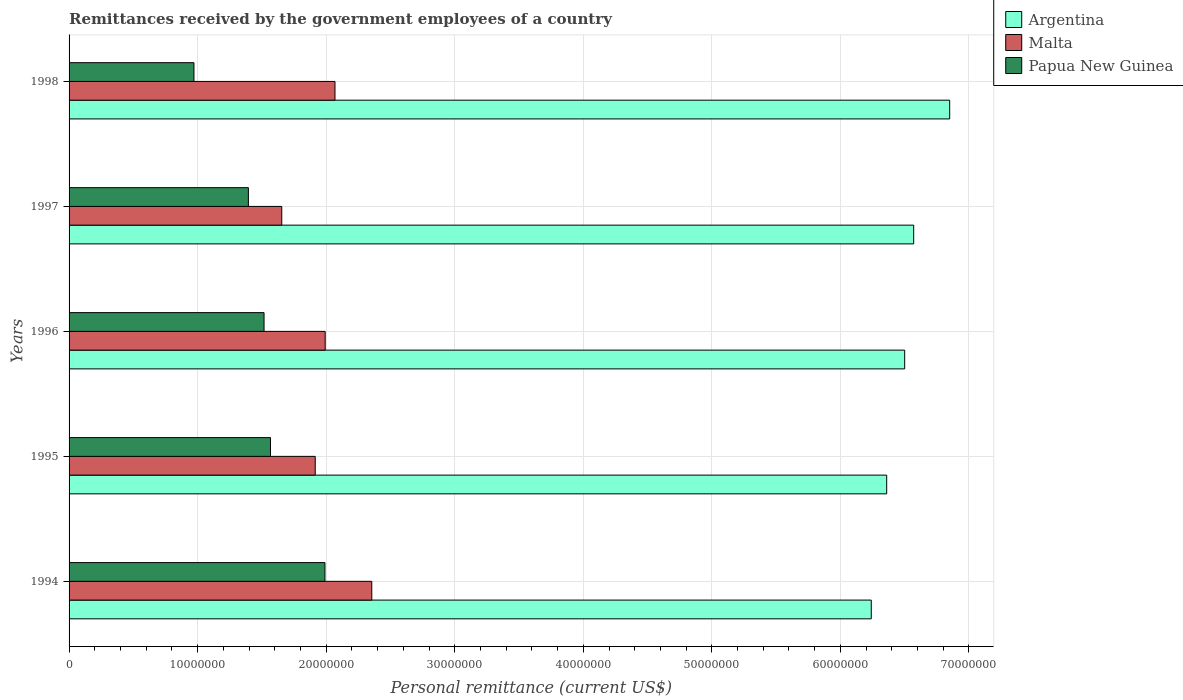How many different coloured bars are there?
Your answer should be very brief. 3. Are the number of bars per tick equal to the number of legend labels?
Offer a terse response. Yes. Are the number of bars on each tick of the Y-axis equal?
Provide a short and direct response. Yes. What is the remittances received by the government employees in Argentina in 1996?
Provide a succinct answer. 6.50e+07. Across all years, what is the maximum remittances received by the government employees in Papua New Guinea?
Offer a very short reply. 1.99e+07. Across all years, what is the minimum remittances received by the government employees in Malta?
Provide a short and direct response. 1.65e+07. In which year was the remittances received by the government employees in Papua New Guinea maximum?
Your answer should be compact. 1994. In which year was the remittances received by the government employees in Malta minimum?
Provide a succinct answer. 1997. What is the total remittances received by the government employees in Argentina in the graph?
Keep it short and to the point. 3.25e+08. What is the difference between the remittances received by the government employees in Malta in 1994 and that in 1996?
Your answer should be compact. 3.62e+06. What is the difference between the remittances received by the government employees in Papua New Guinea in 1994 and the remittances received by the government employees in Malta in 1995?
Provide a succinct answer. 7.56e+05. What is the average remittances received by the government employees in Papua New Guinea per year?
Keep it short and to the point. 1.49e+07. In the year 1994, what is the difference between the remittances received by the government employees in Malta and remittances received by the government employees in Papua New Guinea?
Give a very brief answer. 3.64e+06. What is the ratio of the remittances received by the government employees in Argentina in 1995 to that in 1997?
Your answer should be compact. 0.97. Is the remittances received by the government employees in Malta in 1994 less than that in 1998?
Your answer should be very brief. No. What is the difference between the highest and the second highest remittances received by the government employees in Malta?
Offer a terse response. 2.86e+06. What is the difference between the highest and the lowest remittances received by the government employees in Papua New Guinea?
Your answer should be very brief. 1.02e+07. In how many years, is the remittances received by the government employees in Argentina greater than the average remittances received by the government employees in Argentina taken over all years?
Provide a succinct answer. 2. Is the sum of the remittances received by the government employees in Argentina in 1994 and 1995 greater than the maximum remittances received by the government employees in Papua New Guinea across all years?
Offer a terse response. Yes. What does the 2nd bar from the top in 1996 represents?
Offer a very short reply. Malta. What does the 1st bar from the bottom in 1996 represents?
Your answer should be very brief. Argentina. How many bars are there?
Keep it short and to the point. 15. Does the graph contain any zero values?
Keep it short and to the point. No. Does the graph contain grids?
Offer a terse response. Yes. How are the legend labels stacked?
Offer a very short reply. Vertical. What is the title of the graph?
Your response must be concise. Remittances received by the government employees of a country. Does "Myanmar" appear as one of the legend labels in the graph?
Your response must be concise. No. What is the label or title of the X-axis?
Offer a terse response. Personal remittance (current US$). What is the Personal remittance (current US$) in Argentina in 1994?
Your answer should be compact. 6.24e+07. What is the Personal remittance (current US$) in Malta in 1994?
Ensure brevity in your answer.  2.35e+07. What is the Personal remittance (current US$) of Papua New Guinea in 1994?
Ensure brevity in your answer.  1.99e+07. What is the Personal remittance (current US$) of Argentina in 1995?
Provide a short and direct response. 6.36e+07. What is the Personal remittance (current US$) of Malta in 1995?
Ensure brevity in your answer.  1.91e+07. What is the Personal remittance (current US$) in Papua New Guinea in 1995?
Your response must be concise. 1.57e+07. What is the Personal remittance (current US$) in Argentina in 1996?
Your answer should be very brief. 6.50e+07. What is the Personal remittance (current US$) in Malta in 1996?
Your answer should be very brief. 1.99e+07. What is the Personal remittance (current US$) of Papua New Guinea in 1996?
Your response must be concise. 1.52e+07. What is the Personal remittance (current US$) of Argentina in 1997?
Make the answer very short. 6.57e+07. What is the Personal remittance (current US$) of Malta in 1997?
Provide a succinct answer. 1.65e+07. What is the Personal remittance (current US$) of Papua New Guinea in 1997?
Your answer should be very brief. 1.39e+07. What is the Personal remittance (current US$) in Argentina in 1998?
Offer a very short reply. 6.85e+07. What is the Personal remittance (current US$) of Malta in 1998?
Give a very brief answer. 2.07e+07. What is the Personal remittance (current US$) in Papua New Guinea in 1998?
Give a very brief answer. 9.71e+06. Across all years, what is the maximum Personal remittance (current US$) in Argentina?
Offer a terse response. 6.85e+07. Across all years, what is the maximum Personal remittance (current US$) in Malta?
Offer a terse response. 2.35e+07. Across all years, what is the maximum Personal remittance (current US$) in Papua New Guinea?
Offer a very short reply. 1.99e+07. Across all years, what is the minimum Personal remittance (current US$) in Argentina?
Provide a succinct answer. 6.24e+07. Across all years, what is the minimum Personal remittance (current US$) in Malta?
Offer a very short reply. 1.65e+07. Across all years, what is the minimum Personal remittance (current US$) of Papua New Guinea?
Offer a terse response. 9.71e+06. What is the total Personal remittance (current US$) in Argentina in the graph?
Keep it short and to the point. 3.25e+08. What is the total Personal remittance (current US$) in Malta in the graph?
Ensure brevity in your answer.  9.98e+07. What is the total Personal remittance (current US$) in Papua New Guinea in the graph?
Provide a succinct answer. 7.44e+07. What is the difference between the Personal remittance (current US$) of Argentina in 1994 and that in 1995?
Give a very brief answer. -1.20e+06. What is the difference between the Personal remittance (current US$) of Malta in 1994 and that in 1995?
Ensure brevity in your answer.  4.40e+06. What is the difference between the Personal remittance (current US$) of Papua New Guinea in 1994 and that in 1995?
Make the answer very short. 4.24e+06. What is the difference between the Personal remittance (current US$) in Argentina in 1994 and that in 1996?
Offer a very short reply. -2.60e+06. What is the difference between the Personal remittance (current US$) of Malta in 1994 and that in 1996?
Your response must be concise. 3.62e+06. What is the difference between the Personal remittance (current US$) of Papua New Guinea in 1994 and that in 1996?
Provide a short and direct response. 4.74e+06. What is the difference between the Personal remittance (current US$) in Argentina in 1994 and that in 1997?
Your answer should be very brief. -3.30e+06. What is the difference between the Personal remittance (current US$) in Malta in 1994 and that in 1997?
Make the answer very short. 7.00e+06. What is the difference between the Personal remittance (current US$) in Papua New Guinea in 1994 and that in 1997?
Give a very brief answer. 5.96e+06. What is the difference between the Personal remittance (current US$) of Argentina in 1994 and that in 1998?
Offer a very short reply. -6.10e+06. What is the difference between the Personal remittance (current US$) of Malta in 1994 and that in 1998?
Offer a very short reply. 2.86e+06. What is the difference between the Personal remittance (current US$) in Papua New Guinea in 1994 and that in 1998?
Offer a very short reply. 1.02e+07. What is the difference between the Personal remittance (current US$) of Argentina in 1995 and that in 1996?
Provide a succinct answer. -1.40e+06. What is the difference between the Personal remittance (current US$) in Malta in 1995 and that in 1996?
Offer a very short reply. -7.74e+05. What is the difference between the Personal remittance (current US$) in Papua New Guinea in 1995 and that in 1996?
Your answer should be compact. 5.01e+05. What is the difference between the Personal remittance (current US$) in Argentina in 1995 and that in 1997?
Ensure brevity in your answer.  -2.10e+06. What is the difference between the Personal remittance (current US$) of Malta in 1995 and that in 1997?
Ensure brevity in your answer.  2.60e+06. What is the difference between the Personal remittance (current US$) of Papua New Guinea in 1995 and that in 1997?
Give a very brief answer. 1.72e+06. What is the difference between the Personal remittance (current US$) in Argentina in 1995 and that in 1998?
Keep it short and to the point. -4.90e+06. What is the difference between the Personal remittance (current US$) in Malta in 1995 and that in 1998?
Provide a short and direct response. -1.54e+06. What is the difference between the Personal remittance (current US$) of Papua New Guinea in 1995 and that in 1998?
Provide a succinct answer. 5.95e+06. What is the difference between the Personal remittance (current US$) of Argentina in 1996 and that in 1997?
Your answer should be compact. -7.00e+05. What is the difference between the Personal remittance (current US$) in Malta in 1996 and that in 1997?
Ensure brevity in your answer.  3.38e+06. What is the difference between the Personal remittance (current US$) of Papua New Guinea in 1996 and that in 1997?
Give a very brief answer. 1.22e+06. What is the difference between the Personal remittance (current US$) of Argentina in 1996 and that in 1998?
Provide a short and direct response. -3.50e+06. What is the difference between the Personal remittance (current US$) in Malta in 1996 and that in 1998?
Keep it short and to the point. -7.62e+05. What is the difference between the Personal remittance (current US$) of Papua New Guinea in 1996 and that in 1998?
Make the answer very short. 5.45e+06. What is the difference between the Personal remittance (current US$) in Argentina in 1997 and that in 1998?
Offer a terse response. -2.80e+06. What is the difference between the Personal remittance (current US$) in Malta in 1997 and that in 1998?
Your answer should be compact. -4.14e+06. What is the difference between the Personal remittance (current US$) in Papua New Guinea in 1997 and that in 1998?
Keep it short and to the point. 4.24e+06. What is the difference between the Personal remittance (current US$) of Argentina in 1994 and the Personal remittance (current US$) of Malta in 1995?
Your answer should be very brief. 4.33e+07. What is the difference between the Personal remittance (current US$) in Argentina in 1994 and the Personal remittance (current US$) in Papua New Guinea in 1995?
Your answer should be compact. 4.67e+07. What is the difference between the Personal remittance (current US$) in Malta in 1994 and the Personal remittance (current US$) in Papua New Guinea in 1995?
Make the answer very short. 7.88e+06. What is the difference between the Personal remittance (current US$) of Argentina in 1994 and the Personal remittance (current US$) of Malta in 1996?
Provide a succinct answer. 4.25e+07. What is the difference between the Personal remittance (current US$) of Argentina in 1994 and the Personal remittance (current US$) of Papua New Guinea in 1996?
Give a very brief answer. 4.72e+07. What is the difference between the Personal remittance (current US$) of Malta in 1994 and the Personal remittance (current US$) of Papua New Guinea in 1996?
Give a very brief answer. 8.38e+06. What is the difference between the Personal remittance (current US$) of Argentina in 1994 and the Personal remittance (current US$) of Malta in 1997?
Your answer should be compact. 4.59e+07. What is the difference between the Personal remittance (current US$) of Argentina in 1994 and the Personal remittance (current US$) of Papua New Guinea in 1997?
Offer a terse response. 4.85e+07. What is the difference between the Personal remittance (current US$) of Malta in 1994 and the Personal remittance (current US$) of Papua New Guinea in 1997?
Provide a short and direct response. 9.60e+06. What is the difference between the Personal remittance (current US$) of Argentina in 1994 and the Personal remittance (current US$) of Malta in 1998?
Your answer should be compact. 4.17e+07. What is the difference between the Personal remittance (current US$) in Argentina in 1994 and the Personal remittance (current US$) in Papua New Guinea in 1998?
Provide a short and direct response. 5.27e+07. What is the difference between the Personal remittance (current US$) in Malta in 1994 and the Personal remittance (current US$) in Papua New Guinea in 1998?
Provide a succinct answer. 1.38e+07. What is the difference between the Personal remittance (current US$) in Argentina in 1995 and the Personal remittance (current US$) in Malta in 1996?
Provide a succinct answer. 4.37e+07. What is the difference between the Personal remittance (current US$) of Argentina in 1995 and the Personal remittance (current US$) of Papua New Guinea in 1996?
Make the answer very short. 4.84e+07. What is the difference between the Personal remittance (current US$) of Malta in 1995 and the Personal remittance (current US$) of Papua New Guinea in 1996?
Offer a terse response. 3.98e+06. What is the difference between the Personal remittance (current US$) in Argentina in 1995 and the Personal remittance (current US$) in Malta in 1997?
Keep it short and to the point. 4.71e+07. What is the difference between the Personal remittance (current US$) in Argentina in 1995 and the Personal remittance (current US$) in Papua New Guinea in 1997?
Your answer should be very brief. 4.97e+07. What is the difference between the Personal remittance (current US$) of Malta in 1995 and the Personal remittance (current US$) of Papua New Guinea in 1997?
Ensure brevity in your answer.  5.20e+06. What is the difference between the Personal remittance (current US$) of Argentina in 1995 and the Personal remittance (current US$) of Malta in 1998?
Give a very brief answer. 4.29e+07. What is the difference between the Personal remittance (current US$) in Argentina in 1995 and the Personal remittance (current US$) in Papua New Guinea in 1998?
Your answer should be very brief. 5.39e+07. What is the difference between the Personal remittance (current US$) of Malta in 1995 and the Personal remittance (current US$) of Papua New Guinea in 1998?
Give a very brief answer. 9.43e+06. What is the difference between the Personal remittance (current US$) in Argentina in 1996 and the Personal remittance (current US$) in Malta in 1997?
Provide a short and direct response. 4.85e+07. What is the difference between the Personal remittance (current US$) of Argentina in 1996 and the Personal remittance (current US$) of Papua New Guinea in 1997?
Give a very brief answer. 5.11e+07. What is the difference between the Personal remittance (current US$) of Malta in 1996 and the Personal remittance (current US$) of Papua New Guinea in 1997?
Offer a very short reply. 5.97e+06. What is the difference between the Personal remittance (current US$) of Argentina in 1996 and the Personal remittance (current US$) of Malta in 1998?
Your answer should be compact. 4.43e+07. What is the difference between the Personal remittance (current US$) of Argentina in 1996 and the Personal remittance (current US$) of Papua New Guinea in 1998?
Make the answer very short. 5.53e+07. What is the difference between the Personal remittance (current US$) in Malta in 1996 and the Personal remittance (current US$) in Papua New Guinea in 1998?
Your response must be concise. 1.02e+07. What is the difference between the Personal remittance (current US$) in Argentina in 1997 and the Personal remittance (current US$) in Malta in 1998?
Your answer should be compact. 4.50e+07. What is the difference between the Personal remittance (current US$) in Argentina in 1997 and the Personal remittance (current US$) in Papua New Guinea in 1998?
Ensure brevity in your answer.  5.60e+07. What is the difference between the Personal remittance (current US$) in Malta in 1997 and the Personal remittance (current US$) in Papua New Guinea in 1998?
Your answer should be very brief. 6.83e+06. What is the average Personal remittance (current US$) of Argentina per year?
Your answer should be compact. 6.50e+07. What is the average Personal remittance (current US$) in Malta per year?
Give a very brief answer. 2.00e+07. What is the average Personal remittance (current US$) of Papua New Guinea per year?
Keep it short and to the point. 1.49e+07. In the year 1994, what is the difference between the Personal remittance (current US$) in Argentina and Personal remittance (current US$) in Malta?
Provide a short and direct response. 3.89e+07. In the year 1994, what is the difference between the Personal remittance (current US$) in Argentina and Personal remittance (current US$) in Papua New Guinea?
Make the answer very short. 4.25e+07. In the year 1994, what is the difference between the Personal remittance (current US$) of Malta and Personal remittance (current US$) of Papua New Guinea?
Your answer should be very brief. 3.64e+06. In the year 1995, what is the difference between the Personal remittance (current US$) in Argentina and Personal remittance (current US$) in Malta?
Your answer should be very brief. 4.45e+07. In the year 1995, what is the difference between the Personal remittance (current US$) of Argentina and Personal remittance (current US$) of Papua New Guinea?
Your response must be concise. 4.79e+07. In the year 1995, what is the difference between the Personal remittance (current US$) in Malta and Personal remittance (current US$) in Papua New Guinea?
Your answer should be very brief. 3.48e+06. In the year 1996, what is the difference between the Personal remittance (current US$) in Argentina and Personal remittance (current US$) in Malta?
Provide a short and direct response. 4.51e+07. In the year 1996, what is the difference between the Personal remittance (current US$) of Argentina and Personal remittance (current US$) of Papua New Guinea?
Make the answer very short. 4.98e+07. In the year 1996, what is the difference between the Personal remittance (current US$) in Malta and Personal remittance (current US$) in Papua New Guinea?
Make the answer very short. 4.76e+06. In the year 1997, what is the difference between the Personal remittance (current US$) of Argentina and Personal remittance (current US$) of Malta?
Offer a terse response. 4.92e+07. In the year 1997, what is the difference between the Personal remittance (current US$) of Argentina and Personal remittance (current US$) of Papua New Guinea?
Offer a terse response. 5.18e+07. In the year 1997, what is the difference between the Personal remittance (current US$) in Malta and Personal remittance (current US$) in Papua New Guinea?
Your answer should be compact. 2.60e+06. In the year 1998, what is the difference between the Personal remittance (current US$) in Argentina and Personal remittance (current US$) in Malta?
Give a very brief answer. 4.78e+07. In the year 1998, what is the difference between the Personal remittance (current US$) in Argentina and Personal remittance (current US$) in Papua New Guinea?
Provide a short and direct response. 5.88e+07. In the year 1998, what is the difference between the Personal remittance (current US$) of Malta and Personal remittance (current US$) of Papua New Guinea?
Your answer should be very brief. 1.10e+07. What is the ratio of the Personal remittance (current US$) in Argentina in 1994 to that in 1995?
Your response must be concise. 0.98. What is the ratio of the Personal remittance (current US$) of Malta in 1994 to that in 1995?
Ensure brevity in your answer.  1.23. What is the ratio of the Personal remittance (current US$) in Papua New Guinea in 1994 to that in 1995?
Offer a terse response. 1.27. What is the ratio of the Personal remittance (current US$) of Argentina in 1994 to that in 1996?
Your answer should be compact. 0.96. What is the ratio of the Personal remittance (current US$) of Malta in 1994 to that in 1996?
Give a very brief answer. 1.18. What is the ratio of the Personal remittance (current US$) in Papua New Guinea in 1994 to that in 1996?
Your response must be concise. 1.31. What is the ratio of the Personal remittance (current US$) in Argentina in 1994 to that in 1997?
Your answer should be compact. 0.95. What is the ratio of the Personal remittance (current US$) of Malta in 1994 to that in 1997?
Provide a succinct answer. 1.42. What is the ratio of the Personal remittance (current US$) in Papua New Guinea in 1994 to that in 1997?
Your response must be concise. 1.43. What is the ratio of the Personal remittance (current US$) in Argentina in 1994 to that in 1998?
Give a very brief answer. 0.91. What is the ratio of the Personal remittance (current US$) of Malta in 1994 to that in 1998?
Your answer should be very brief. 1.14. What is the ratio of the Personal remittance (current US$) of Papua New Guinea in 1994 to that in 1998?
Your answer should be very brief. 2.05. What is the ratio of the Personal remittance (current US$) of Argentina in 1995 to that in 1996?
Make the answer very short. 0.98. What is the ratio of the Personal remittance (current US$) of Malta in 1995 to that in 1996?
Your response must be concise. 0.96. What is the ratio of the Personal remittance (current US$) in Papua New Guinea in 1995 to that in 1996?
Provide a succinct answer. 1.03. What is the ratio of the Personal remittance (current US$) in Malta in 1995 to that in 1997?
Make the answer very short. 1.16. What is the ratio of the Personal remittance (current US$) of Papua New Guinea in 1995 to that in 1997?
Offer a terse response. 1.12. What is the ratio of the Personal remittance (current US$) in Argentina in 1995 to that in 1998?
Keep it short and to the point. 0.93. What is the ratio of the Personal remittance (current US$) in Malta in 1995 to that in 1998?
Make the answer very short. 0.93. What is the ratio of the Personal remittance (current US$) in Papua New Guinea in 1995 to that in 1998?
Provide a succinct answer. 1.61. What is the ratio of the Personal remittance (current US$) in Argentina in 1996 to that in 1997?
Your response must be concise. 0.99. What is the ratio of the Personal remittance (current US$) in Malta in 1996 to that in 1997?
Give a very brief answer. 1.2. What is the ratio of the Personal remittance (current US$) of Papua New Guinea in 1996 to that in 1997?
Your response must be concise. 1.09. What is the ratio of the Personal remittance (current US$) in Argentina in 1996 to that in 1998?
Your answer should be compact. 0.95. What is the ratio of the Personal remittance (current US$) of Malta in 1996 to that in 1998?
Ensure brevity in your answer.  0.96. What is the ratio of the Personal remittance (current US$) in Papua New Guinea in 1996 to that in 1998?
Your answer should be compact. 1.56. What is the ratio of the Personal remittance (current US$) in Argentina in 1997 to that in 1998?
Your answer should be compact. 0.96. What is the ratio of the Personal remittance (current US$) of Malta in 1997 to that in 1998?
Your response must be concise. 0.8. What is the ratio of the Personal remittance (current US$) in Papua New Guinea in 1997 to that in 1998?
Your answer should be very brief. 1.44. What is the difference between the highest and the second highest Personal remittance (current US$) of Argentina?
Ensure brevity in your answer.  2.80e+06. What is the difference between the highest and the second highest Personal remittance (current US$) in Malta?
Provide a short and direct response. 2.86e+06. What is the difference between the highest and the second highest Personal remittance (current US$) of Papua New Guinea?
Provide a short and direct response. 4.24e+06. What is the difference between the highest and the lowest Personal remittance (current US$) in Argentina?
Give a very brief answer. 6.10e+06. What is the difference between the highest and the lowest Personal remittance (current US$) of Malta?
Offer a terse response. 7.00e+06. What is the difference between the highest and the lowest Personal remittance (current US$) of Papua New Guinea?
Keep it short and to the point. 1.02e+07. 